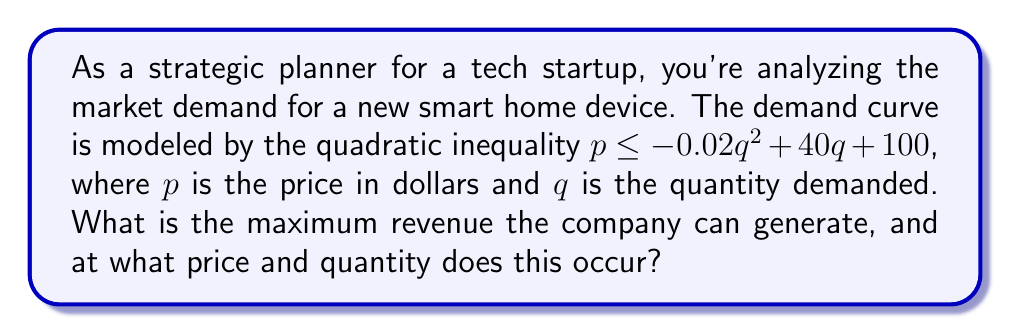Give your solution to this math problem. To solve this problem, we'll follow these steps:

1) The revenue function is given by $R = pq$. We want to maximize this function.

2) At the maximum revenue point, the price will be at the upper bound of the inequality. So we can replace the inequality with an equality:

   $p = -0.02q^2 + 40q + 100$

3) Substituting this into the revenue function:

   $R = q(-0.02q^2 + 40q + 100)$
   $R = -0.02q^3 + 40q^2 + 100q$

4) To find the maximum, we differentiate R with respect to q and set it to zero:

   $\frac{dR}{dq} = -0.06q^2 + 80q + 100 = 0$

5) This is a quadratic equation. We can solve it using the quadratic formula:

   $q = \frac{-b \pm \sqrt{b^2 - 4ac}}{2a}$

   Where $a = -0.06$, $b = 80$, and $c = 100$

6) Solving:

   $q = \frac{-80 \pm \sqrt{80^2 - 4(-0.06)(100)}}{2(-0.06)}$
   $q = \frac{-80 \pm \sqrt{6400 + 24}}{-0.12}$
   $q = \frac{-80 \pm \sqrt{6424}}{-0.12}$
   $q = \frac{-80 \pm 80.15}{-0.12}$

7) This gives us two solutions: $q \approx 1335.8$ or $q \approx 0.2$

   The larger value maximizes revenue, so $q \approx 1335.8$

8) To find the price at this quantity, we substitute back into the original equation:

   $p = -0.02(1335.8)^2 + 40(1335.8) + 100$
   $p \approx 13,458$

9) The maximum revenue is therefore:

   $R = 1335.8 * 13,458 \approx 17,978,000$
Answer: Maximum revenue: $17,978,000; Price: $13,458; Quantity: 1,336 units 